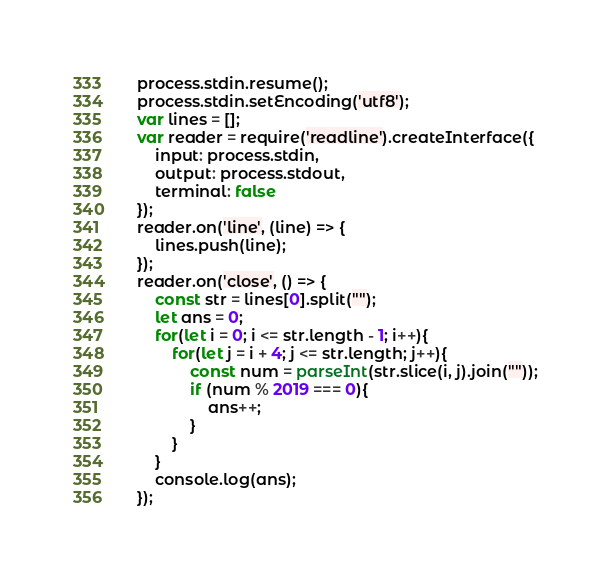<code> <loc_0><loc_0><loc_500><loc_500><_JavaScript_>process.stdin.resume();
process.stdin.setEncoding('utf8');
var lines = [];
var reader = require('readline').createInterface({
    input: process.stdin,
    output: process.stdout,
    terminal: false
});
reader.on('line', (line) => {
    lines.push(line);
});
reader.on('close', () => {
    const str = lines[0].split("");
    let ans = 0;
    for(let i = 0; i <= str.length - 1; i++){
        for(let j = i + 4; j <= str.length; j++){
            const num = parseInt(str.slice(i, j).join(""));
            if (num % 2019 === 0){
                ans++;
            }
        }
    }
    console.log(ans);
});</code> 